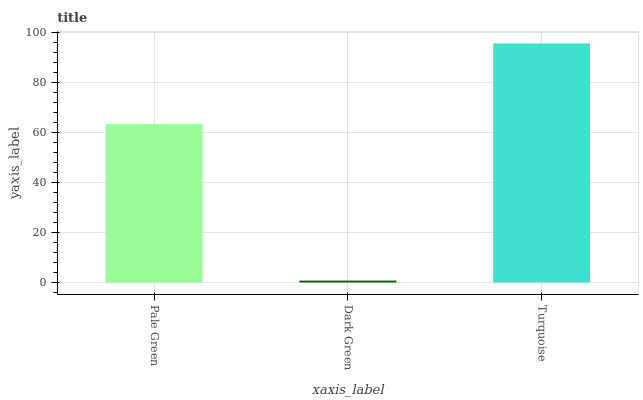Is Dark Green the minimum?
Answer yes or no. Yes. Is Turquoise the maximum?
Answer yes or no. Yes. Is Turquoise the minimum?
Answer yes or no. No. Is Dark Green the maximum?
Answer yes or no. No. Is Turquoise greater than Dark Green?
Answer yes or no. Yes. Is Dark Green less than Turquoise?
Answer yes or no. Yes. Is Dark Green greater than Turquoise?
Answer yes or no. No. Is Turquoise less than Dark Green?
Answer yes or no. No. Is Pale Green the high median?
Answer yes or no. Yes. Is Pale Green the low median?
Answer yes or no. Yes. Is Dark Green the high median?
Answer yes or no. No. Is Dark Green the low median?
Answer yes or no. No. 